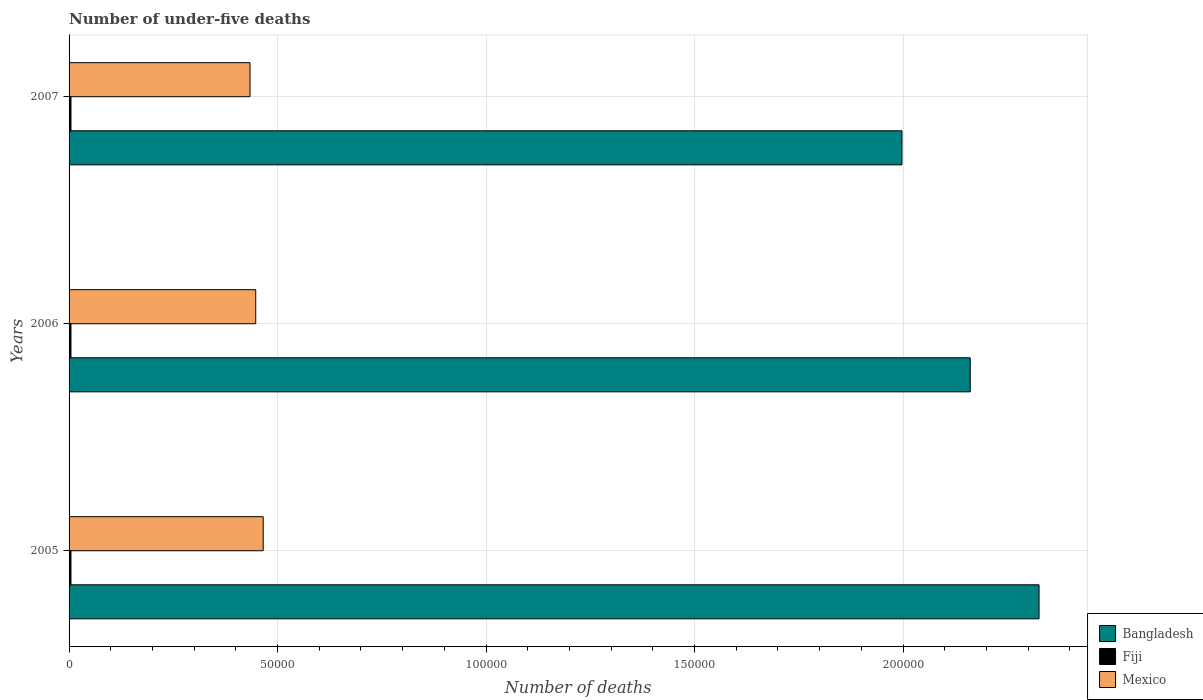How many groups of bars are there?
Give a very brief answer. 3. Are the number of bars on each tick of the Y-axis equal?
Offer a terse response. Yes. What is the label of the 1st group of bars from the top?
Your answer should be compact. 2007. In how many cases, is the number of bars for a given year not equal to the number of legend labels?
Keep it short and to the point. 0. What is the number of under-five deaths in Mexico in 2005?
Your answer should be very brief. 4.66e+04. Across all years, what is the maximum number of under-five deaths in Fiji?
Your answer should be compact. 458. Across all years, what is the minimum number of under-five deaths in Bangladesh?
Provide a succinct answer. 2.00e+05. What is the total number of under-five deaths in Fiji in the graph?
Offer a very short reply. 1368. What is the difference between the number of under-five deaths in Fiji in 2006 and that in 2007?
Make the answer very short. -2. What is the difference between the number of under-five deaths in Mexico in 2006 and the number of under-five deaths in Fiji in 2005?
Your response must be concise. 4.43e+04. What is the average number of under-five deaths in Fiji per year?
Your response must be concise. 456. In the year 2007, what is the difference between the number of under-five deaths in Mexico and number of under-five deaths in Bangladesh?
Provide a succinct answer. -1.56e+05. In how many years, is the number of under-five deaths in Mexico greater than 20000 ?
Keep it short and to the point. 3. What is the ratio of the number of under-five deaths in Bangladesh in 2005 to that in 2006?
Offer a very short reply. 1.08. Is the number of under-five deaths in Bangladesh in 2005 less than that in 2006?
Keep it short and to the point. No. Is the difference between the number of under-five deaths in Mexico in 2006 and 2007 greater than the difference between the number of under-five deaths in Bangladesh in 2006 and 2007?
Ensure brevity in your answer.  No. What is the difference between the highest and the second highest number of under-five deaths in Mexico?
Provide a succinct answer. 1790. What is the difference between the highest and the lowest number of under-five deaths in Fiji?
Keep it short and to the point. 4. Is the sum of the number of under-five deaths in Bangladesh in 2005 and 2006 greater than the maximum number of under-five deaths in Fiji across all years?
Provide a short and direct response. Yes. What does the 2nd bar from the bottom in 2006 represents?
Provide a succinct answer. Fiji. Is it the case that in every year, the sum of the number of under-five deaths in Fiji and number of under-five deaths in Bangladesh is greater than the number of under-five deaths in Mexico?
Keep it short and to the point. Yes. How many bars are there?
Keep it short and to the point. 9. How many years are there in the graph?
Your answer should be compact. 3. Are the values on the major ticks of X-axis written in scientific E-notation?
Your answer should be compact. No. How many legend labels are there?
Give a very brief answer. 3. How are the legend labels stacked?
Offer a very short reply. Vertical. What is the title of the graph?
Provide a short and direct response. Number of under-five deaths. What is the label or title of the X-axis?
Offer a very short reply. Number of deaths. What is the Number of deaths in Bangladesh in 2005?
Give a very brief answer. 2.33e+05. What is the Number of deaths of Fiji in 2005?
Provide a short and direct response. 454. What is the Number of deaths in Mexico in 2005?
Provide a short and direct response. 4.66e+04. What is the Number of deaths of Bangladesh in 2006?
Ensure brevity in your answer.  2.16e+05. What is the Number of deaths in Fiji in 2006?
Make the answer very short. 456. What is the Number of deaths in Mexico in 2006?
Make the answer very short. 4.48e+04. What is the Number of deaths in Bangladesh in 2007?
Make the answer very short. 2.00e+05. What is the Number of deaths of Fiji in 2007?
Keep it short and to the point. 458. What is the Number of deaths in Mexico in 2007?
Your response must be concise. 4.34e+04. Across all years, what is the maximum Number of deaths in Bangladesh?
Provide a short and direct response. 2.33e+05. Across all years, what is the maximum Number of deaths in Fiji?
Provide a succinct answer. 458. Across all years, what is the maximum Number of deaths in Mexico?
Keep it short and to the point. 4.66e+04. Across all years, what is the minimum Number of deaths of Bangladesh?
Give a very brief answer. 2.00e+05. Across all years, what is the minimum Number of deaths in Fiji?
Ensure brevity in your answer.  454. Across all years, what is the minimum Number of deaths in Mexico?
Make the answer very short. 4.34e+04. What is the total Number of deaths of Bangladesh in the graph?
Provide a succinct answer. 6.48e+05. What is the total Number of deaths in Fiji in the graph?
Give a very brief answer. 1368. What is the total Number of deaths of Mexico in the graph?
Your answer should be very brief. 1.35e+05. What is the difference between the Number of deaths in Bangladesh in 2005 and that in 2006?
Offer a terse response. 1.65e+04. What is the difference between the Number of deaths of Fiji in 2005 and that in 2006?
Offer a terse response. -2. What is the difference between the Number of deaths of Mexico in 2005 and that in 2006?
Make the answer very short. 1790. What is the difference between the Number of deaths in Bangladesh in 2005 and that in 2007?
Your response must be concise. 3.29e+04. What is the difference between the Number of deaths in Fiji in 2005 and that in 2007?
Ensure brevity in your answer.  -4. What is the difference between the Number of deaths of Mexico in 2005 and that in 2007?
Keep it short and to the point. 3168. What is the difference between the Number of deaths of Bangladesh in 2006 and that in 2007?
Your response must be concise. 1.64e+04. What is the difference between the Number of deaths in Mexico in 2006 and that in 2007?
Your answer should be compact. 1378. What is the difference between the Number of deaths in Bangladesh in 2005 and the Number of deaths in Fiji in 2006?
Keep it short and to the point. 2.32e+05. What is the difference between the Number of deaths in Bangladesh in 2005 and the Number of deaths in Mexico in 2006?
Offer a terse response. 1.88e+05. What is the difference between the Number of deaths in Fiji in 2005 and the Number of deaths in Mexico in 2006?
Provide a short and direct response. -4.43e+04. What is the difference between the Number of deaths of Bangladesh in 2005 and the Number of deaths of Fiji in 2007?
Provide a short and direct response. 2.32e+05. What is the difference between the Number of deaths in Bangladesh in 2005 and the Number of deaths in Mexico in 2007?
Provide a short and direct response. 1.89e+05. What is the difference between the Number of deaths in Fiji in 2005 and the Number of deaths in Mexico in 2007?
Your answer should be compact. -4.29e+04. What is the difference between the Number of deaths in Bangladesh in 2006 and the Number of deaths in Fiji in 2007?
Your response must be concise. 2.16e+05. What is the difference between the Number of deaths of Bangladesh in 2006 and the Number of deaths of Mexico in 2007?
Offer a terse response. 1.73e+05. What is the difference between the Number of deaths of Fiji in 2006 and the Number of deaths of Mexico in 2007?
Offer a terse response. -4.29e+04. What is the average Number of deaths of Bangladesh per year?
Provide a short and direct response. 2.16e+05. What is the average Number of deaths of Fiji per year?
Ensure brevity in your answer.  456. What is the average Number of deaths in Mexico per year?
Offer a very short reply. 4.49e+04. In the year 2005, what is the difference between the Number of deaths in Bangladesh and Number of deaths in Fiji?
Offer a terse response. 2.32e+05. In the year 2005, what is the difference between the Number of deaths of Bangladesh and Number of deaths of Mexico?
Give a very brief answer. 1.86e+05. In the year 2005, what is the difference between the Number of deaths of Fiji and Number of deaths of Mexico?
Provide a succinct answer. -4.61e+04. In the year 2006, what is the difference between the Number of deaths in Bangladesh and Number of deaths in Fiji?
Your response must be concise. 2.16e+05. In the year 2006, what is the difference between the Number of deaths in Bangladesh and Number of deaths in Mexico?
Make the answer very short. 1.71e+05. In the year 2006, what is the difference between the Number of deaths in Fiji and Number of deaths in Mexico?
Your answer should be compact. -4.43e+04. In the year 2007, what is the difference between the Number of deaths of Bangladesh and Number of deaths of Fiji?
Your answer should be compact. 1.99e+05. In the year 2007, what is the difference between the Number of deaths of Bangladesh and Number of deaths of Mexico?
Provide a short and direct response. 1.56e+05. In the year 2007, what is the difference between the Number of deaths of Fiji and Number of deaths of Mexico?
Your answer should be compact. -4.29e+04. What is the ratio of the Number of deaths of Bangladesh in 2005 to that in 2006?
Ensure brevity in your answer.  1.08. What is the ratio of the Number of deaths of Fiji in 2005 to that in 2006?
Your response must be concise. 1. What is the ratio of the Number of deaths in Mexico in 2005 to that in 2006?
Make the answer very short. 1.04. What is the ratio of the Number of deaths in Bangladesh in 2005 to that in 2007?
Make the answer very short. 1.16. What is the ratio of the Number of deaths in Fiji in 2005 to that in 2007?
Give a very brief answer. 0.99. What is the ratio of the Number of deaths in Mexico in 2005 to that in 2007?
Your answer should be compact. 1.07. What is the ratio of the Number of deaths of Bangladesh in 2006 to that in 2007?
Your answer should be very brief. 1.08. What is the ratio of the Number of deaths in Fiji in 2006 to that in 2007?
Provide a succinct answer. 1. What is the ratio of the Number of deaths in Mexico in 2006 to that in 2007?
Ensure brevity in your answer.  1.03. What is the difference between the highest and the second highest Number of deaths of Bangladesh?
Ensure brevity in your answer.  1.65e+04. What is the difference between the highest and the second highest Number of deaths in Mexico?
Keep it short and to the point. 1790. What is the difference between the highest and the lowest Number of deaths of Bangladesh?
Offer a terse response. 3.29e+04. What is the difference between the highest and the lowest Number of deaths in Mexico?
Ensure brevity in your answer.  3168. 